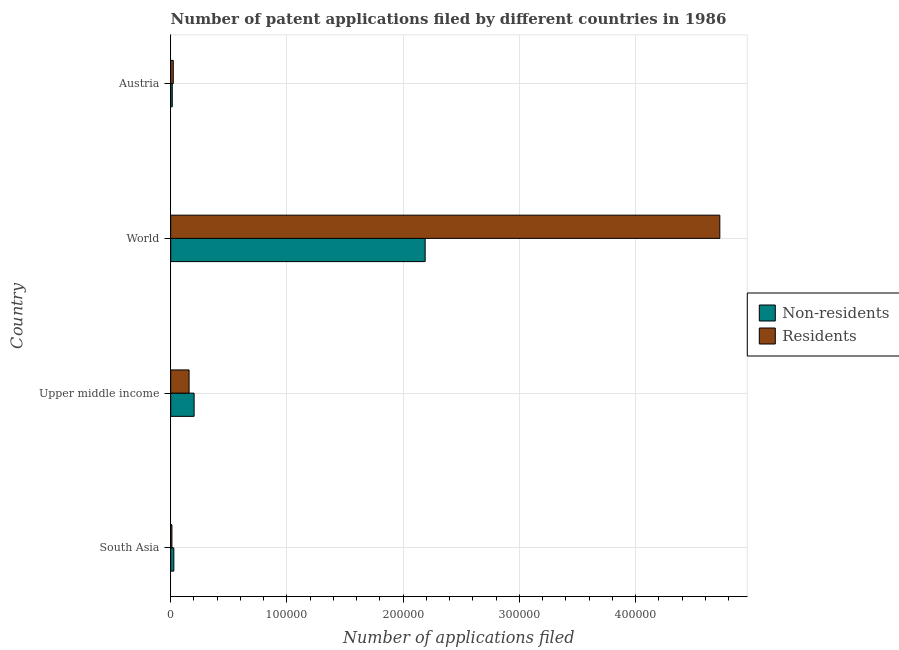How many different coloured bars are there?
Your answer should be compact. 2. How many groups of bars are there?
Your response must be concise. 4. How many bars are there on the 4th tick from the bottom?
Your answer should be very brief. 2. In how many cases, is the number of bars for a given country not equal to the number of legend labels?
Your response must be concise. 0. What is the number of patent applications by non residents in South Asia?
Your answer should be very brief. 2677. Across all countries, what is the maximum number of patent applications by residents?
Provide a succinct answer. 4.72e+05. Across all countries, what is the minimum number of patent applications by residents?
Provide a short and direct response. 1041. In which country was the number of patent applications by residents maximum?
Your answer should be very brief. World. In which country was the number of patent applications by non residents minimum?
Offer a very short reply. Austria. What is the total number of patent applications by residents in the graph?
Ensure brevity in your answer.  4.91e+05. What is the difference between the number of patent applications by residents in Upper middle income and that in World?
Give a very brief answer. -4.57e+05. What is the difference between the number of patent applications by non residents in South Asia and the number of patent applications by residents in Upper middle income?
Offer a terse response. -1.31e+04. What is the average number of patent applications by non residents per country?
Offer a terse response. 6.08e+04. What is the difference between the number of patent applications by non residents and number of patent applications by residents in Austria?
Provide a short and direct response. -874. In how many countries, is the number of patent applications by non residents greater than 280000 ?
Your response must be concise. 0. What is the ratio of the number of patent applications by non residents in Austria to that in South Asia?
Keep it short and to the point. 0.5. Is the difference between the number of patent applications by residents in South Asia and World greater than the difference between the number of patent applications by non residents in South Asia and World?
Ensure brevity in your answer.  No. What is the difference between the highest and the second highest number of patent applications by residents?
Keep it short and to the point. 4.57e+05. What is the difference between the highest and the lowest number of patent applications by non residents?
Keep it short and to the point. 2.18e+05. What does the 2nd bar from the top in Austria represents?
Give a very brief answer. Non-residents. What does the 2nd bar from the bottom in Austria represents?
Make the answer very short. Residents. How many bars are there?
Give a very brief answer. 8. Does the graph contain grids?
Provide a succinct answer. Yes. Where does the legend appear in the graph?
Provide a succinct answer. Center right. How many legend labels are there?
Offer a very short reply. 2. How are the legend labels stacked?
Ensure brevity in your answer.  Vertical. What is the title of the graph?
Give a very brief answer. Number of patent applications filed by different countries in 1986. Does "Education" appear as one of the legend labels in the graph?
Your answer should be very brief. No. What is the label or title of the X-axis?
Your response must be concise. Number of applications filed. What is the Number of applications filed of Non-residents in South Asia?
Offer a terse response. 2677. What is the Number of applications filed in Residents in South Asia?
Make the answer very short. 1041. What is the Number of applications filed in Non-residents in Upper middle income?
Give a very brief answer. 2.01e+04. What is the Number of applications filed of Residents in Upper middle income?
Your answer should be very brief. 1.58e+04. What is the Number of applications filed in Non-residents in World?
Keep it short and to the point. 2.19e+05. What is the Number of applications filed in Residents in World?
Your answer should be very brief. 4.72e+05. What is the Number of applications filed in Non-residents in Austria?
Your answer should be compact. 1336. What is the Number of applications filed of Residents in Austria?
Provide a succinct answer. 2210. Across all countries, what is the maximum Number of applications filed in Non-residents?
Ensure brevity in your answer.  2.19e+05. Across all countries, what is the maximum Number of applications filed in Residents?
Ensure brevity in your answer.  4.72e+05. Across all countries, what is the minimum Number of applications filed in Non-residents?
Give a very brief answer. 1336. Across all countries, what is the minimum Number of applications filed in Residents?
Offer a very short reply. 1041. What is the total Number of applications filed of Non-residents in the graph?
Give a very brief answer. 2.43e+05. What is the total Number of applications filed in Residents in the graph?
Offer a terse response. 4.91e+05. What is the difference between the Number of applications filed in Non-residents in South Asia and that in Upper middle income?
Your answer should be very brief. -1.74e+04. What is the difference between the Number of applications filed in Residents in South Asia and that in Upper middle income?
Your response must be concise. -1.48e+04. What is the difference between the Number of applications filed of Non-residents in South Asia and that in World?
Make the answer very short. -2.16e+05. What is the difference between the Number of applications filed of Residents in South Asia and that in World?
Ensure brevity in your answer.  -4.71e+05. What is the difference between the Number of applications filed of Non-residents in South Asia and that in Austria?
Provide a short and direct response. 1341. What is the difference between the Number of applications filed in Residents in South Asia and that in Austria?
Your response must be concise. -1169. What is the difference between the Number of applications filed of Non-residents in Upper middle income and that in World?
Your answer should be very brief. -1.99e+05. What is the difference between the Number of applications filed in Residents in Upper middle income and that in World?
Ensure brevity in your answer.  -4.57e+05. What is the difference between the Number of applications filed in Non-residents in Upper middle income and that in Austria?
Keep it short and to the point. 1.88e+04. What is the difference between the Number of applications filed in Residents in Upper middle income and that in Austria?
Give a very brief answer. 1.36e+04. What is the difference between the Number of applications filed of Non-residents in World and that in Austria?
Offer a very short reply. 2.18e+05. What is the difference between the Number of applications filed in Residents in World and that in Austria?
Your answer should be compact. 4.70e+05. What is the difference between the Number of applications filed in Non-residents in South Asia and the Number of applications filed in Residents in Upper middle income?
Your answer should be compact. -1.31e+04. What is the difference between the Number of applications filed of Non-residents in South Asia and the Number of applications filed of Residents in World?
Give a very brief answer. -4.70e+05. What is the difference between the Number of applications filed of Non-residents in South Asia and the Number of applications filed of Residents in Austria?
Your answer should be compact. 467. What is the difference between the Number of applications filed in Non-residents in Upper middle income and the Number of applications filed in Residents in World?
Your answer should be compact. -4.52e+05. What is the difference between the Number of applications filed in Non-residents in Upper middle income and the Number of applications filed in Residents in Austria?
Make the answer very short. 1.79e+04. What is the difference between the Number of applications filed in Non-residents in World and the Number of applications filed in Residents in Austria?
Provide a succinct answer. 2.17e+05. What is the average Number of applications filed of Non-residents per country?
Provide a succinct answer. 6.08e+04. What is the average Number of applications filed of Residents per country?
Your answer should be very brief. 1.23e+05. What is the difference between the Number of applications filed in Non-residents and Number of applications filed in Residents in South Asia?
Offer a terse response. 1636. What is the difference between the Number of applications filed in Non-residents and Number of applications filed in Residents in Upper middle income?
Offer a terse response. 4326. What is the difference between the Number of applications filed of Non-residents and Number of applications filed of Residents in World?
Offer a terse response. -2.54e+05. What is the difference between the Number of applications filed of Non-residents and Number of applications filed of Residents in Austria?
Make the answer very short. -874. What is the ratio of the Number of applications filed in Non-residents in South Asia to that in Upper middle income?
Provide a short and direct response. 0.13. What is the ratio of the Number of applications filed in Residents in South Asia to that in Upper middle income?
Offer a very short reply. 0.07. What is the ratio of the Number of applications filed in Non-residents in South Asia to that in World?
Provide a short and direct response. 0.01. What is the ratio of the Number of applications filed in Residents in South Asia to that in World?
Make the answer very short. 0. What is the ratio of the Number of applications filed of Non-residents in South Asia to that in Austria?
Keep it short and to the point. 2. What is the ratio of the Number of applications filed in Residents in South Asia to that in Austria?
Your response must be concise. 0.47. What is the ratio of the Number of applications filed of Non-residents in Upper middle income to that in World?
Make the answer very short. 0.09. What is the ratio of the Number of applications filed of Residents in Upper middle income to that in World?
Offer a terse response. 0.03. What is the ratio of the Number of applications filed of Non-residents in Upper middle income to that in Austria?
Give a very brief answer. 15.06. What is the ratio of the Number of applications filed of Residents in Upper middle income to that in Austria?
Your answer should be compact. 7.15. What is the ratio of the Number of applications filed of Non-residents in World to that in Austria?
Make the answer very short. 163.86. What is the ratio of the Number of applications filed of Residents in World to that in Austria?
Your response must be concise. 213.78. What is the difference between the highest and the second highest Number of applications filed in Non-residents?
Your answer should be compact. 1.99e+05. What is the difference between the highest and the second highest Number of applications filed in Residents?
Give a very brief answer. 4.57e+05. What is the difference between the highest and the lowest Number of applications filed of Non-residents?
Provide a succinct answer. 2.18e+05. What is the difference between the highest and the lowest Number of applications filed in Residents?
Your answer should be compact. 4.71e+05. 